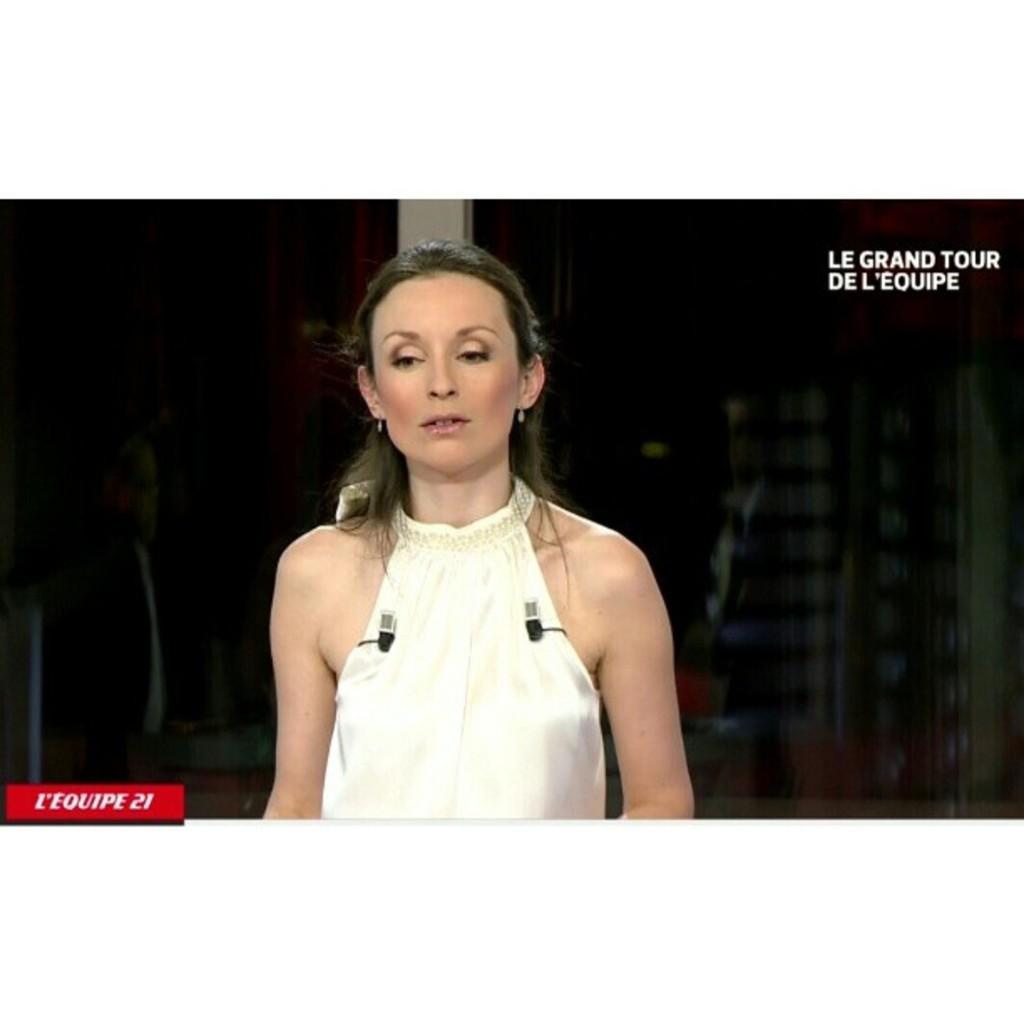Who is the main subject in the image? There is a woman in the image. What can be seen behind the woman? There are objects visible behind the woman. How would you describe the lighting in the image? The setting is dark. Where can text be found in the image? There is text in the top right corner and the bottom left corner of the image. Are there any cobwebs visible in the image? There is no mention of cobwebs in the provided facts, and therefore we cannot determine if any are present in the image. 